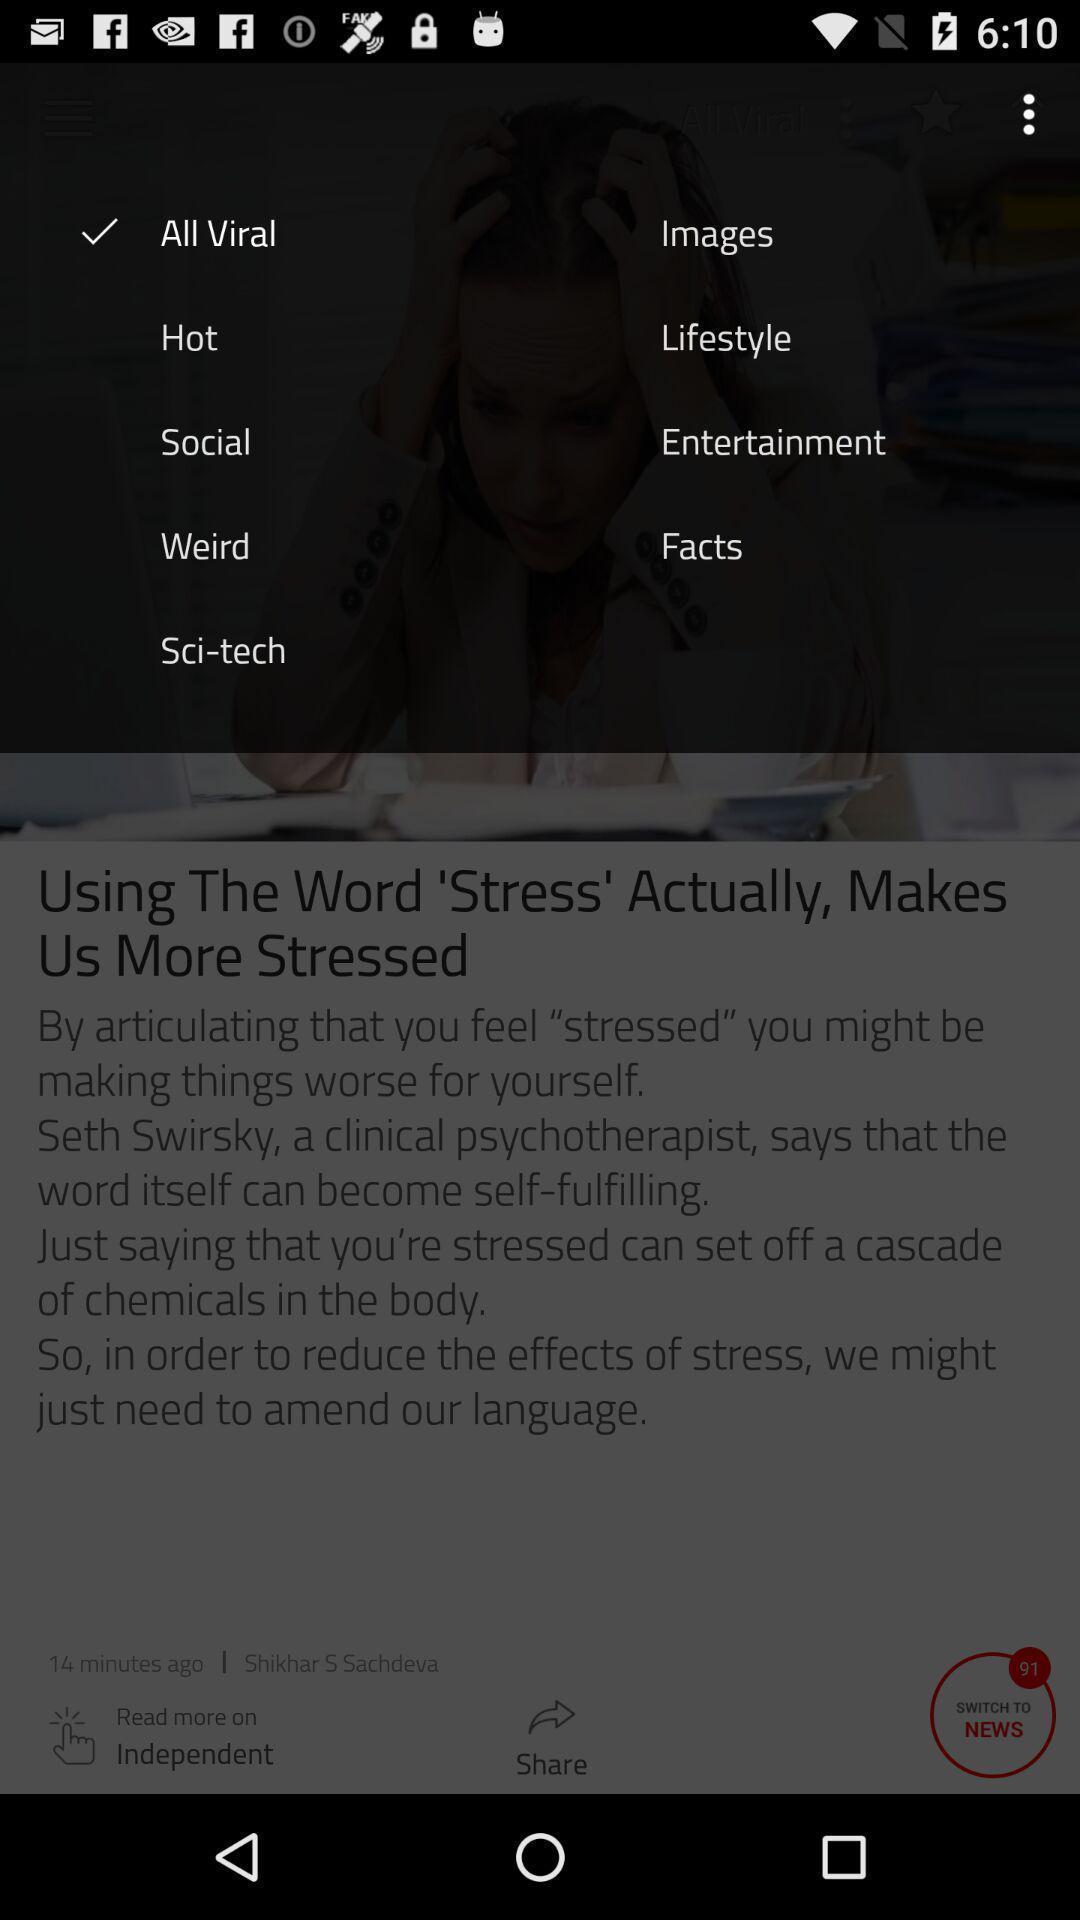Give me a narrative description of this picture. Pop-up displaying the list of categories. 